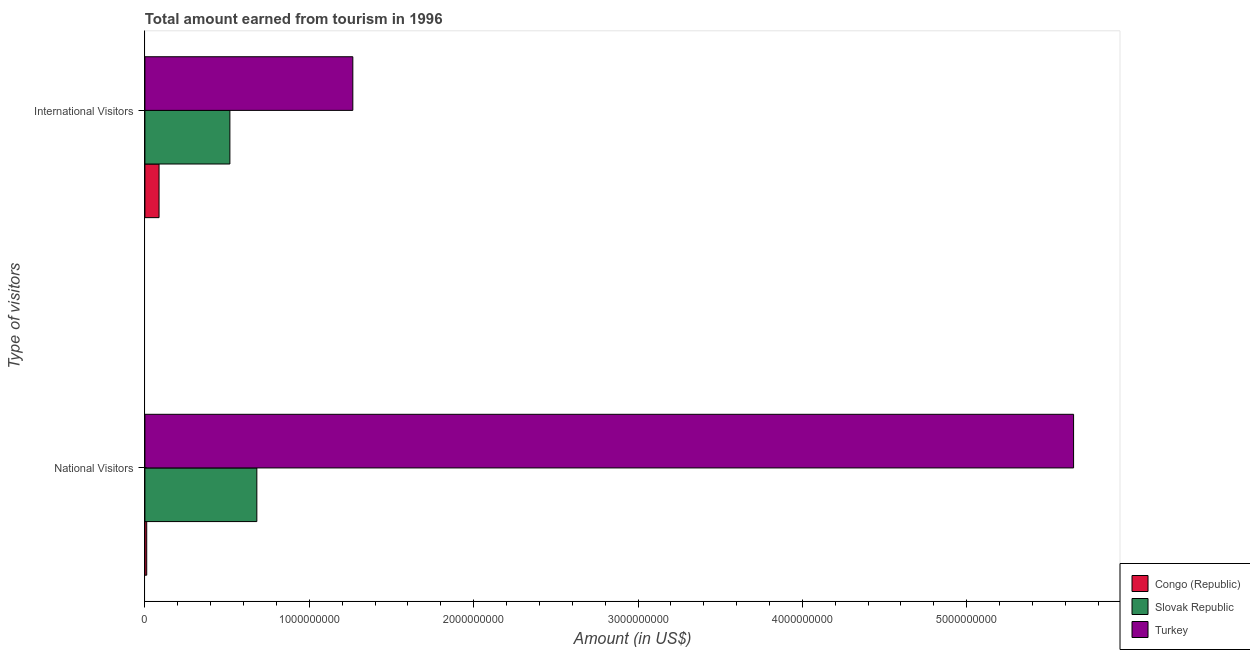How many different coloured bars are there?
Provide a succinct answer. 3. How many groups of bars are there?
Your answer should be compact. 2. How many bars are there on the 1st tick from the top?
Your answer should be very brief. 3. What is the label of the 1st group of bars from the top?
Give a very brief answer. International Visitors. What is the amount earned from national visitors in Congo (Republic)?
Provide a succinct answer. 1.10e+07. Across all countries, what is the maximum amount earned from international visitors?
Offer a very short reply. 1.26e+09. Across all countries, what is the minimum amount earned from international visitors?
Provide a short and direct response. 8.60e+07. In which country was the amount earned from national visitors maximum?
Your response must be concise. Turkey. In which country was the amount earned from international visitors minimum?
Keep it short and to the point. Congo (Republic). What is the total amount earned from national visitors in the graph?
Offer a very short reply. 6.34e+09. What is the difference between the amount earned from international visitors in Congo (Republic) and that in Turkey?
Your answer should be very brief. -1.18e+09. What is the difference between the amount earned from international visitors in Congo (Republic) and the amount earned from national visitors in Turkey?
Provide a succinct answer. -5.56e+09. What is the average amount earned from national visitors per country?
Your answer should be very brief. 2.11e+09. What is the difference between the amount earned from national visitors and amount earned from international visitors in Congo (Republic)?
Make the answer very short. -7.50e+07. In how many countries, is the amount earned from national visitors greater than 800000000 US$?
Keep it short and to the point. 1. What is the ratio of the amount earned from international visitors in Slovak Republic to that in Congo (Republic)?
Keep it short and to the point. 6.01. In how many countries, is the amount earned from international visitors greater than the average amount earned from international visitors taken over all countries?
Offer a very short reply. 1. What does the 3rd bar from the top in International Visitors represents?
Offer a terse response. Congo (Republic). What does the 2nd bar from the bottom in International Visitors represents?
Provide a succinct answer. Slovak Republic. Are all the bars in the graph horizontal?
Keep it short and to the point. Yes. How many countries are there in the graph?
Keep it short and to the point. 3. What is the difference between two consecutive major ticks on the X-axis?
Offer a very short reply. 1.00e+09. Does the graph contain any zero values?
Your response must be concise. No. Where does the legend appear in the graph?
Offer a very short reply. Bottom right. What is the title of the graph?
Your answer should be compact. Total amount earned from tourism in 1996. Does "Australia" appear as one of the legend labels in the graph?
Ensure brevity in your answer.  No. What is the label or title of the X-axis?
Ensure brevity in your answer.  Amount (in US$). What is the label or title of the Y-axis?
Your answer should be compact. Type of visitors. What is the Amount (in US$) in Congo (Republic) in National Visitors?
Provide a succinct answer. 1.10e+07. What is the Amount (in US$) in Slovak Republic in National Visitors?
Provide a succinct answer. 6.81e+08. What is the Amount (in US$) of Turkey in National Visitors?
Your response must be concise. 5.65e+09. What is the Amount (in US$) of Congo (Republic) in International Visitors?
Your response must be concise. 8.60e+07. What is the Amount (in US$) of Slovak Republic in International Visitors?
Offer a very short reply. 5.17e+08. What is the Amount (in US$) in Turkey in International Visitors?
Give a very brief answer. 1.26e+09. Across all Type of visitors, what is the maximum Amount (in US$) of Congo (Republic)?
Your answer should be compact. 8.60e+07. Across all Type of visitors, what is the maximum Amount (in US$) in Slovak Republic?
Offer a terse response. 6.81e+08. Across all Type of visitors, what is the maximum Amount (in US$) in Turkey?
Offer a very short reply. 5.65e+09. Across all Type of visitors, what is the minimum Amount (in US$) in Congo (Republic)?
Your answer should be compact. 1.10e+07. Across all Type of visitors, what is the minimum Amount (in US$) in Slovak Republic?
Your answer should be very brief. 5.17e+08. Across all Type of visitors, what is the minimum Amount (in US$) of Turkey?
Your response must be concise. 1.26e+09. What is the total Amount (in US$) of Congo (Republic) in the graph?
Provide a succinct answer. 9.70e+07. What is the total Amount (in US$) in Slovak Republic in the graph?
Keep it short and to the point. 1.20e+09. What is the total Amount (in US$) in Turkey in the graph?
Ensure brevity in your answer.  6.92e+09. What is the difference between the Amount (in US$) in Congo (Republic) in National Visitors and that in International Visitors?
Make the answer very short. -7.50e+07. What is the difference between the Amount (in US$) in Slovak Republic in National Visitors and that in International Visitors?
Provide a short and direct response. 1.64e+08. What is the difference between the Amount (in US$) in Turkey in National Visitors and that in International Visitors?
Provide a short and direct response. 4.38e+09. What is the difference between the Amount (in US$) of Congo (Republic) in National Visitors and the Amount (in US$) of Slovak Republic in International Visitors?
Keep it short and to the point. -5.06e+08. What is the difference between the Amount (in US$) of Congo (Republic) in National Visitors and the Amount (in US$) of Turkey in International Visitors?
Your answer should be very brief. -1.25e+09. What is the difference between the Amount (in US$) in Slovak Republic in National Visitors and the Amount (in US$) in Turkey in International Visitors?
Ensure brevity in your answer.  -5.84e+08. What is the average Amount (in US$) of Congo (Republic) per Type of visitors?
Provide a succinct answer. 4.85e+07. What is the average Amount (in US$) of Slovak Republic per Type of visitors?
Your answer should be very brief. 5.99e+08. What is the average Amount (in US$) in Turkey per Type of visitors?
Keep it short and to the point. 3.46e+09. What is the difference between the Amount (in US$) in Congo (Republic) and Amount (in US$) in Slovak Republic in National Visitors?
Provide a succinct answer. -6.70e+08. What is the difference between the Amount (in US$) of Congo (Republic) and Amount (in US$) of Turkey in National Visitors?
Your response must be concise. -5.64e+09. What is the difference between the Amount (in US$) in Slovak Republic and Amount (in US$) in Turkey in National Visitors?
Your answer should be compact. -4.97e+09. What is the difference between the Amount (in US$) in Congo (Republic) and Amount (in US$) in Slovak Republic in International Visitors?
Offer a very short reply. -4.31e+08. What is the difference between the Amount (in US$) in Congo (Republic) and Amount (in US$) in Turkey in International Visitors?
Make the answer very short. -1.18e+09. What is the difference between the Amount (in US$) of Slovak Republic and Amount (in US$) of Turkey in International Visitors?
Your answer should be compact. -7.48e+08. What is the ratio of the Amount (in US$) of Congo (Republic) in National Visitors to that in International Visitors?
Your answer should be very brief. 0.13. What is the ratio of the Amount (in US$) in Slovak Republic in National Visitors to that in International Visitors?
Your answer should be compact. 1.32. What is the ratio of the Amount (in US$) in Turkey in National Visitors to that in International Visitors?
Offer a very short reply. 4.47. What is the difference between the highest and the second highest Amount (in US$) of Congo (Republic)?
Offer a very short reply. 7.50e+07. What is the difference between the highest and the second highest Amount (in US$) in Slovak Republic?
Provide a short and direct response. 1.64e+08. What is the difference between the highest and the second highest Amount (in US$) of Turkey?
Offer a terse response. 4.38e+09. What is the difference between the highest and the lowest Amount (in US$) of Congo (Republic)?
Your answer should be very brief. 7.50e+07. What is the difference between the highest and the lowest Amount (in US$) in Slovak Republic?
Offer a terse response. 1.64e+08. What is the difference between the highest and the lowest Amount (in US$) in Turkey?
Offer a very short reply. 4.38e+09. 